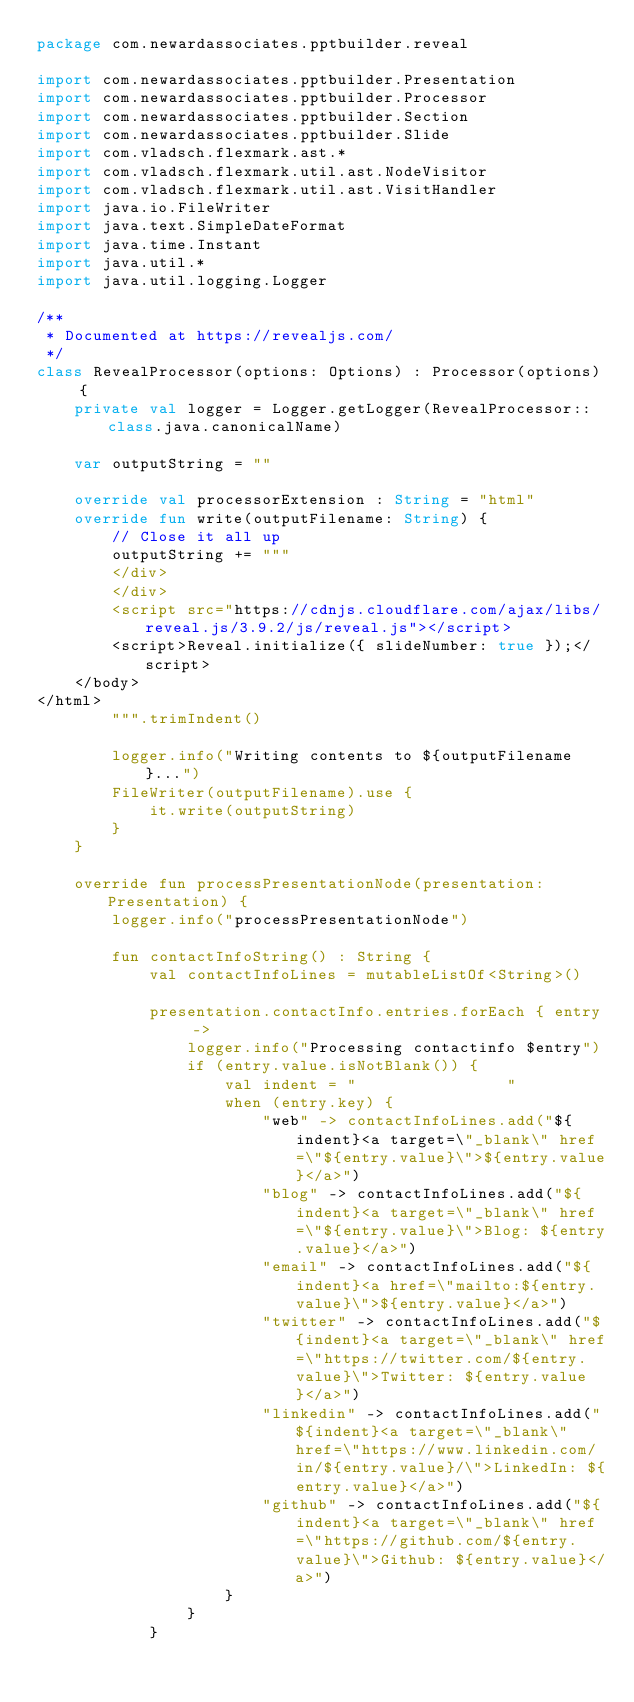<code> <loc_0><loc_0><loc_500><loc_500><_Kotlin_>package com.newardassociates.pptbuilder.reveal

import com.newardassociates.pptbuilder.Presentation
import com.newardassociates.pptbuilder.Processor
import com.newardassociates.pptbuilder.Section
import com.newardassociates.pptbuilder.Slide
import com.vladsch.flexmark.ast.*
import com.vladsch.flexmark.util.ast.NodeVisitor
import com.vladsch.flexmark.util.ast.VisitHandler
import java.io.FileWriter
import java.text.SimpleDateFormat
import java.time.Instant
import java.util.*
import java.util.logging.Logger

/**
 * Documented at https://revealjs.com/
 */
class RevealProcessor(options: Options) : Processor(options) {
    private val logger = Logger.getLogger(RevealProcessor::class.java.canonicalName)

    var outputString = ""

    override val processorExtension : String = "html"
    override fun write(outputFilename: String) {
        // Close it all up
        outputString += """
        </div>
        </div>
        <script src="https://cdnjs.cloudflare.com/ajax/libs/reveal.js/3.9.2/js/reveal.js"></script>
        <script>Reveal.initialize({ slideNumber: true });</script>
    </body>
</html>
        """.trimIndent()

        logger.info("Writing contents to ${outputFilename}...")
        FileWriter(outputFilename).use {
            it.write(outputString)
        }
    }

    override fun processPresentationNode(presentation: Presentation) {
        logger.info("processPresentationNode")

        fun contactInfoString() : String {
            val contactInfoLines = mutableListOf<String>()

            presentation.contactInfo.entries.forEach { entry ->
                logger.info("Processing contactinfo $entry")
                if (entry.value.isNotBlank()) {
                    val indent = "                "
                    when (entry.key) {
                        "web" -> contactInfoLines.add("${indent}<a target=\"_blank\" href=\"${entry.value}\">${entry.value}</a>")
                        "blog" -> contactInfoLines.add("${indent}<a target=\"_blank\" href=\"${entry.value}\">Blog: ${entry.value}</a>")
                        "email" -> contactInfoLines.add("${indent}<a href=\"mailto:${entry.value}\">${entry.value}</a>")
                        "twitter" -> contactInfoLines.add("${indent}<a target=\"_blank\" href=\"https://twitter.com/${entry.value}\">Twitter: ${entry.value}</a>")
                        "linkedin" -> contactInfoLines.add("${indent}<a target=\"_blank\" href=\"https://www.linkedin.com/in/${entry.value}/\">LinkedIn: ${entry.value}</a>")
                        "github" -> contactInfoLines.add("${indent}<a target=\"_blank\" href=\"https://github.com/${entry.value}\">Github: ${entry.value}</a>")
                    }
                }
            }
</code> 